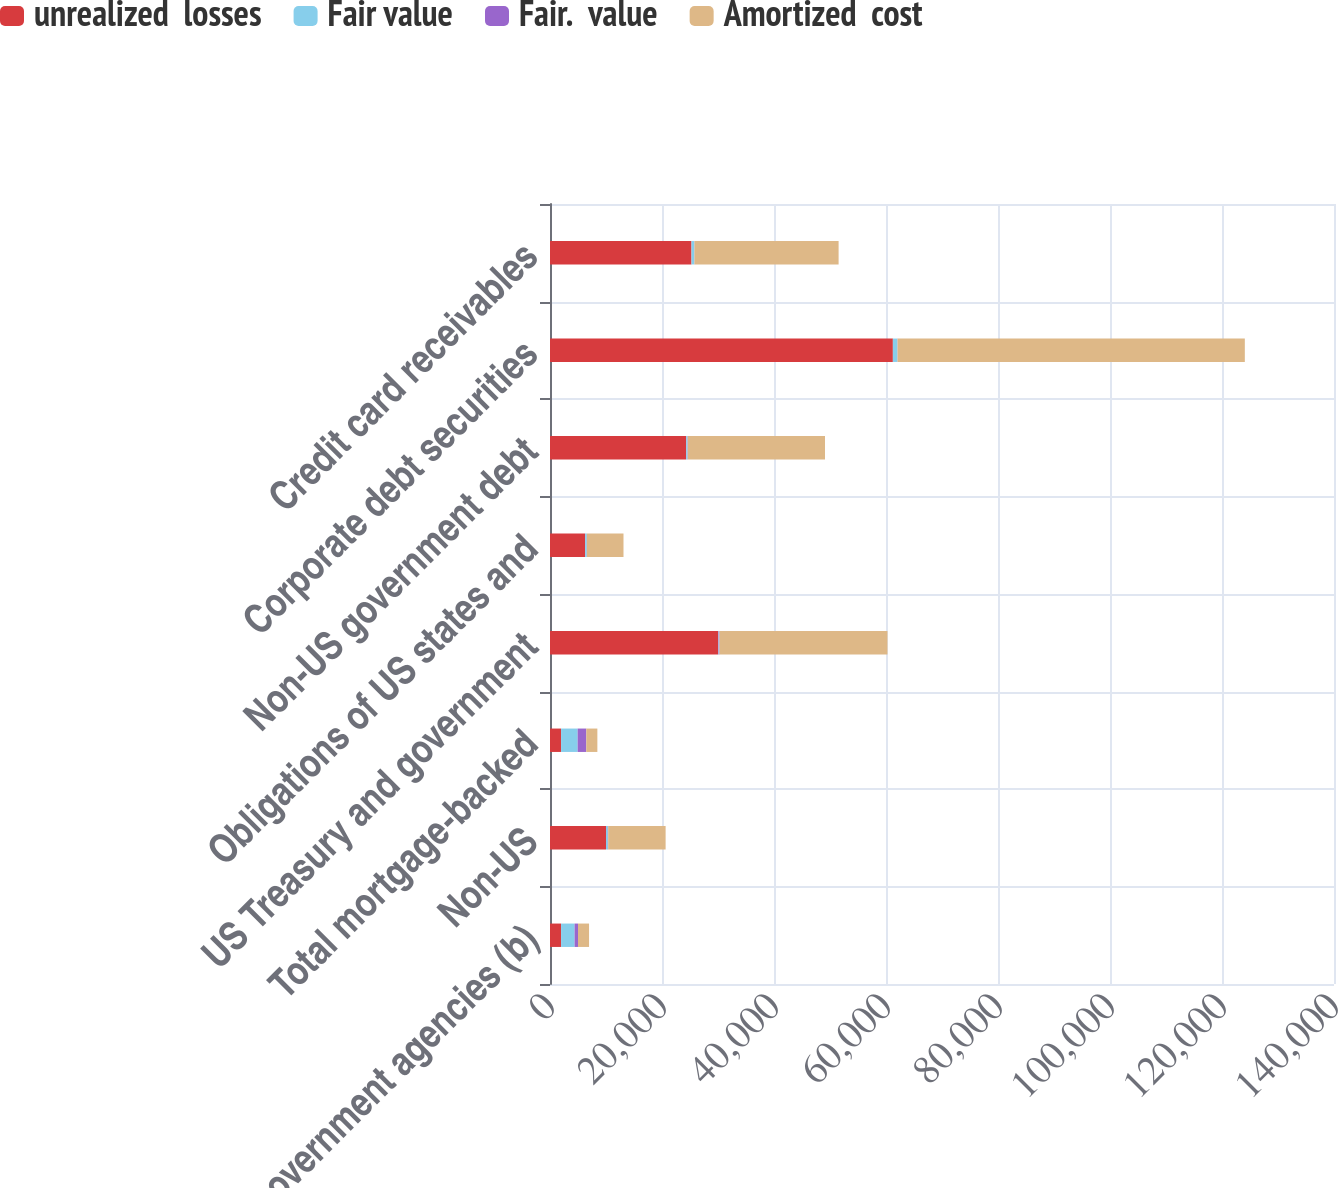Convert chart to OTSL. <chart><loc_0><loc_0><loc_500><loc_500><stacked_bar_chart><ecel><fcel>US government agencies (b)<fcel>Non-US<fcel>Total mortgage-backed<fcel>US Treasury and government<fcel>Obligations of US states and<fcel>Non-US government debt<fcel>Corporate debt securities<fcel>Credit card receivables<nl><fcel>unrealized  losses<fcel>1977.5<fcel>10003<fcel>1977.5<fcel>30044<fcel>6270<fcel>24320<fcel>61226<fcel>25266<nl><fcel>Fair value<fcel>2412<fcel>320<fcel>2960<fcel>88<fcel>292<fcel>234<fcel>812<fcel>502<nl><fcel>Fair.  value<fcel>608<fcel>65<fcel>1543<fcel>135<fcel>25<fcel>51<fcel>30<fcel>26<nl><fcel>Amortized  cost<fcel>1977.5<fcel>10258<fcel>1977.5<fcel>29997<fcel>6537<fcel>24503<fcel>62008<fcel>25742<nl></chart> 